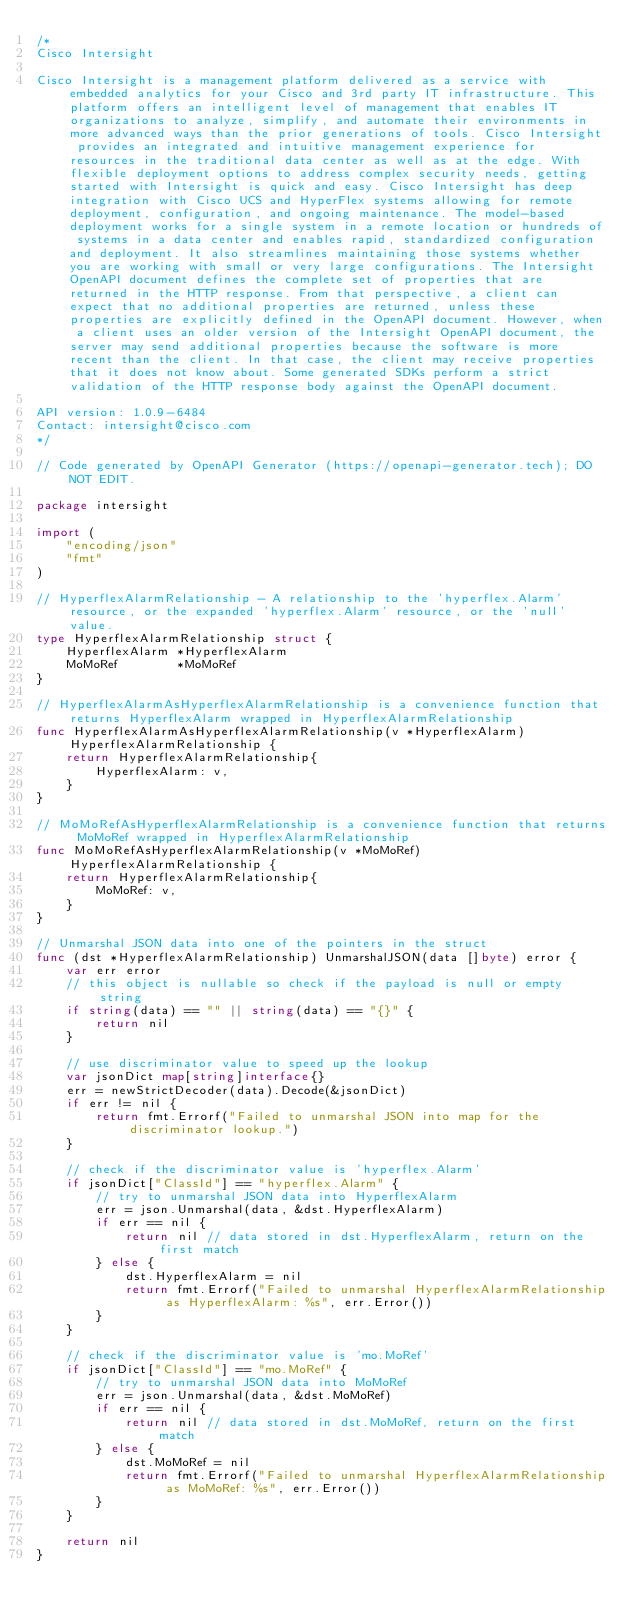<code> <loc_0><loc_0><loc_500><loc_500><_Go_>/*
Cisco Intersight

Cisco Intersight is a management platform delivered as a service with embedded analytics for your Cisco and 3rd party IT infrastructure. This platform offers an intelligent level of management that enables IT organizations to analyze, simplify, and automate their environments in more advanced ways than the prior generations of tools. Cisco Intersight provides an integrated and intuitive management experience for resources in the traditional data center as well as at the edge. With flexible deployment options to address complex security needs, getting started with Intersight is quick and easy. Cisco Intersight has deep integration with Cisco UCS and HyperFlex systems allowing for remote deployment, configuration, and ongoing maintenance. The model-based deployment works for a single system in a remote location or hundreds of systems in a data center and enables rapid, standardized configuration and deployment. It also streamlines maintaining those systems whether you are working with small or very large configurations. The Intersight OpenAPI document defines the complete set of properties that are returned in the HTTP response. From that perspective, a client can expect that no additional properties are returned, unless these properties are explicitly defined in the OpenAPI document. However, when a client uses an older version of the Intersight OpenAPI document, the server may send additional properties because the software is more recent than the client. In that case, the client may receive properties that it does not know about. Some generated SDKs perform a strict validation of the HTTP response body against the OpenAPI document.

API version: 1.0.9-6484
Contact: intersight@cisco.com
*/

// Code generated by OpenAPI Generator (https://openapi-generator.tech); DO NOT EDIT.

package intersight

import (
	"encoding/json"
	"fmt"
)

// HyperflexAlarmRelationship - A relationship to the 'hyperflex.Alarm' resource, or the expanded 'hyperflex.Alarm' resource, or the 'null' value.
type HyperflexAlarmRelationship struct {
	HyperflexAlarm *HyperflexAlarm
	MoMoRef        *MoMoRef
}

// HyperflexAlarmAsHyperflexAlarmRelationship is a convenience function that returns HyperflexAlarm wrapped in HyperflexAlarmRelationship
func HyperflexAlarmAsHyperflexAlarmRelationship(v *HyperflexAlarm) HyperflexAlarmRelationship {
	return HyperflexAlarmRelationship{
		HyperflexAlarm: v,
	}
}

// MoMoRefAsHyperflexAlarmRelationship is a convenience function that returns MoMoRef wrapped in HyperflexAlarmRelationship
func MoMoRefAsHyperflexAlarmRelationship(v *MoMoRef) HyperflexAlarmRelationship {
	return HyperflexAlarmRelationship{
		MoMoRef: v,
	}
}

// Unmarshal JSON data into one of the pointers in the struct
func (dst *HyperflexAlarmRelationship) UnmarshalJSON(data []byte) error {
	var err error
	// this object is nullable so check if the payload is null or empty string
	if string(data) == "" || string(data) == "{}" {
		return nil
	}

	// use discriminator value to speed up the lookup
	var jsonDict map[string]interface{}
	err = newStrictDecoder(data).Decode(&jsonDict)
	if err != nil {
		return fmt.Errorf("Failed to unmarshal JSON into map for the discriminator lookup.")
	}

	// check if the discriminator value is 'hyperflex.Alarm'
	if jsonDict["ClassId"] == "hyperflex.Alarm" {
		// try to unmarshal JSON data into HyperflexAlarm
		err = json.Unmarshal(data, &dst.HyperflexAlarm)
		if err == nil {
			return nil // data stored in dst.HyperflexAlarm, return on the first match
		} else {
			dst.HyperflexAlarm = nil
			return fmt.Errorf("Failed to unmarshal HyperflexAlarmRelationship as HyperflexAlarm: %s", err.Error())
		}
	}

	// check if the discriminator value is 'mo.MoRef'
	if jsonDict["ClassId"] == "mo.MoRef" {
		// try to unmarshal JSON data into MoMoRef
		err = json.Unmarshal(data, &dst.MoMoRef)
		if err == nil {
			return nil // data stored in dst.MoMoRef, return on the first match
		} else {
			dst.MoMoRef = nil
			return fmt.Errorf("Failed to unmarshal HyperflexAlarmRelationship as MoMoRef: %s", err.Error())
		}
	}

	return nil
}
</code> 